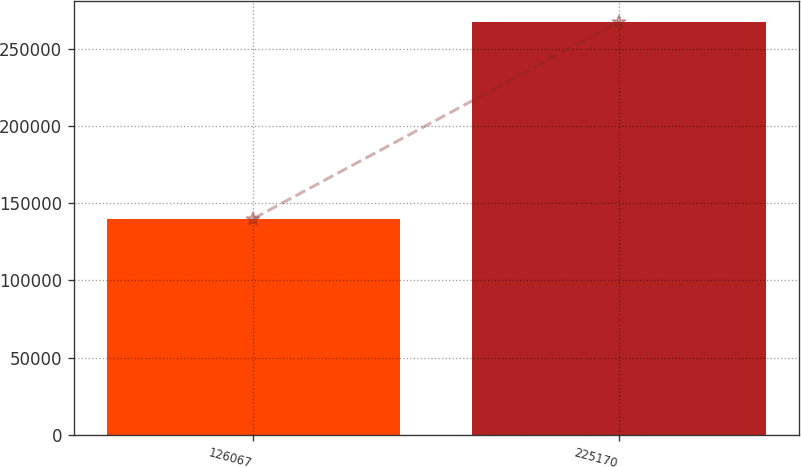Convert chart to OTSL. <chart><loc_0><loc_0><loc_500><loc_500><bar_chart><fcel>126067<fcel>225170<nl><fcel>140160<fcel>267748<nl></chart> 